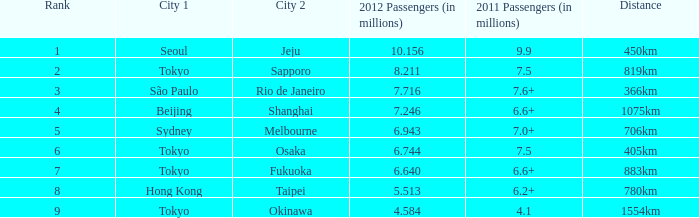Which city is listed first when Okinawa is listed as the second city? Tokyo. 